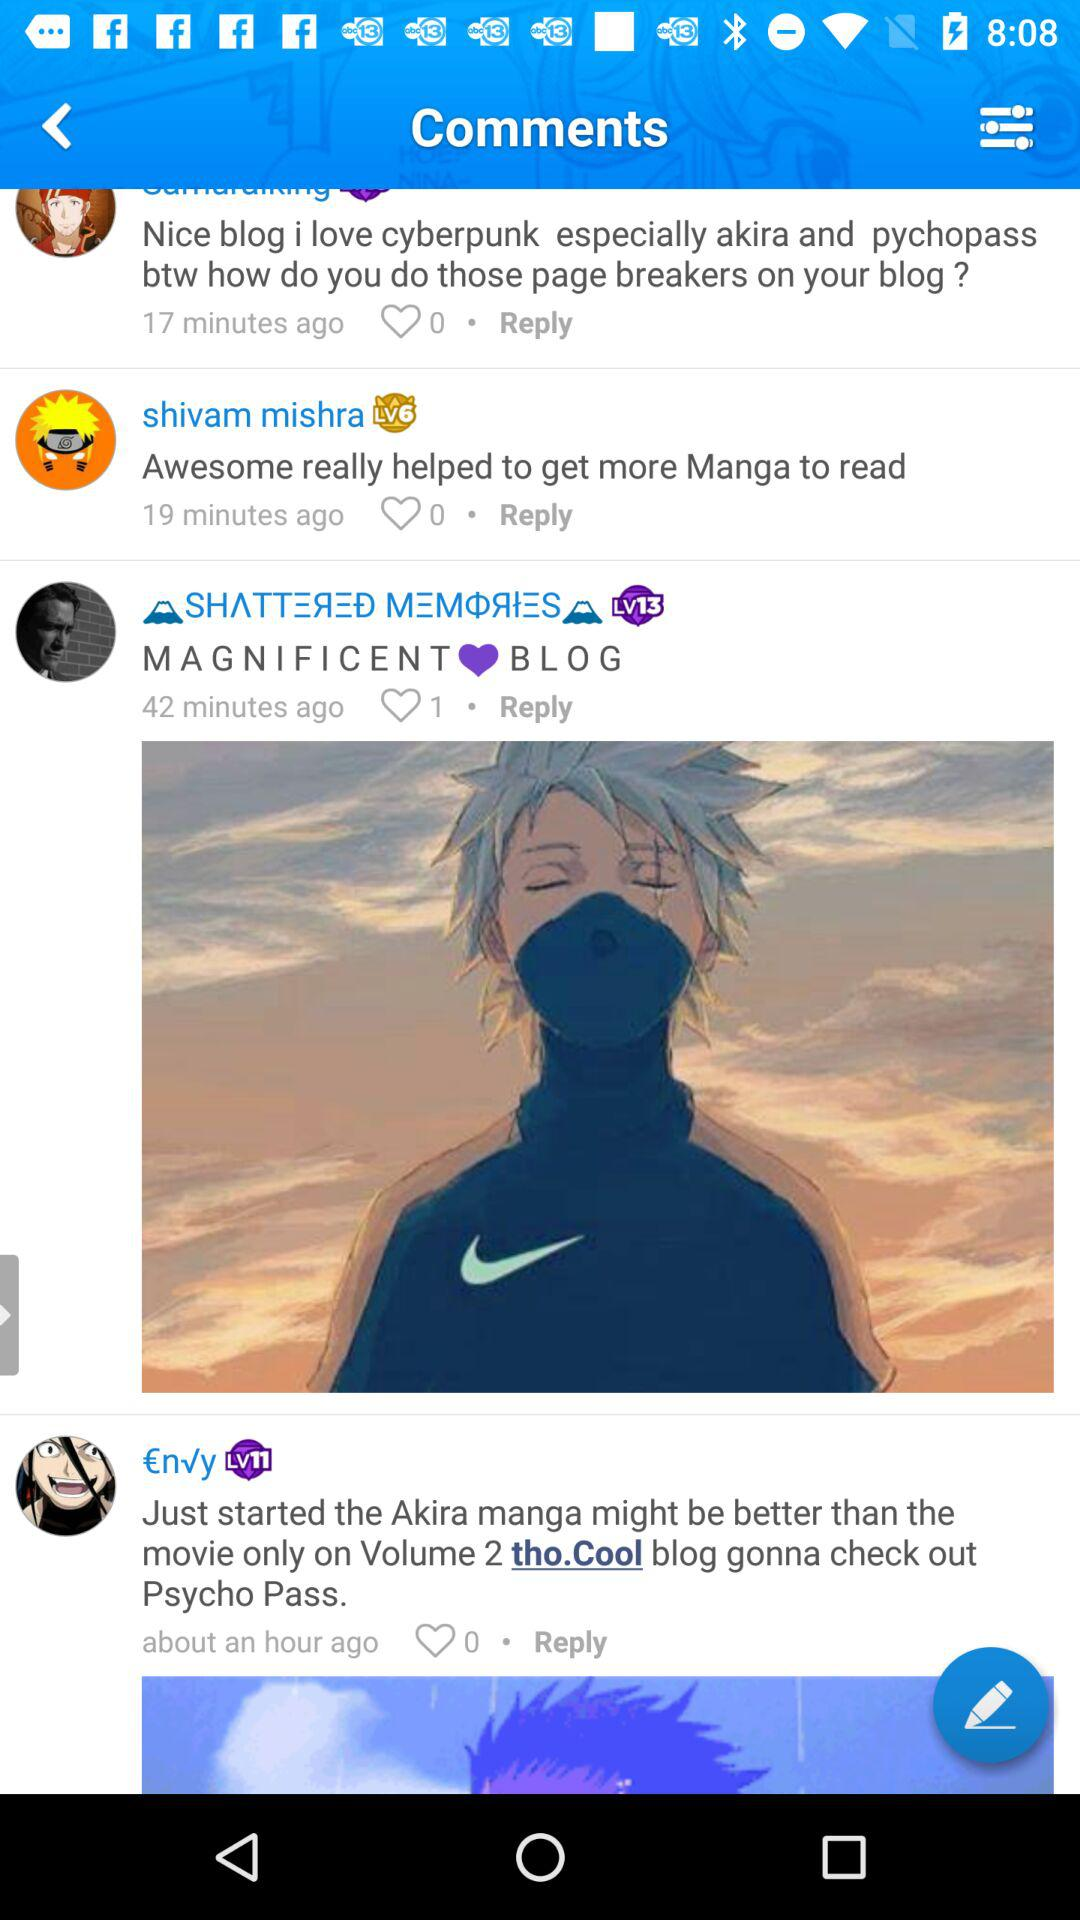What is the number of likes of Shivam Mishra's comment? There are 0 likes of Shivam Mishra's comment. 